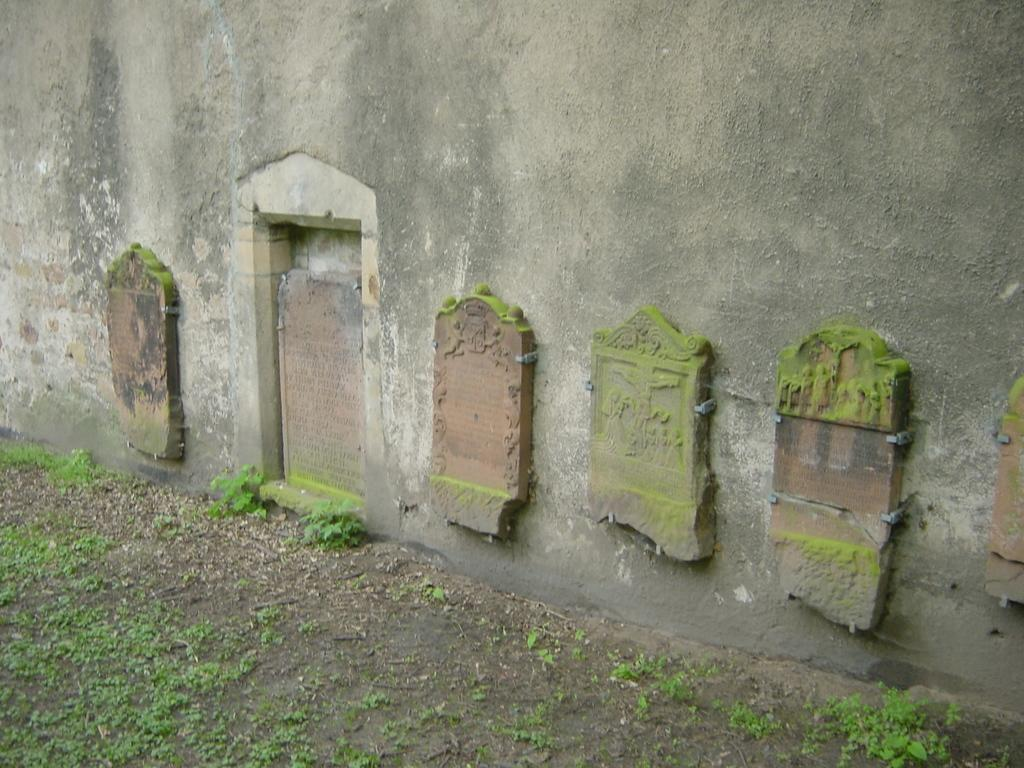What is at the bottom of the picture? There is soil and herbs at the bottom of the picture. What can be seen in the background of the image? There is a wall in the image. What is placed on the wall? Carved stones or carved wood are placed on the wall. How many bikes are leaning against the wall in the image? There are no bikes present in the image; it features soil, herbs, a wall, and carved stones or carved wood. Can you see a wing on any of the carved objects in the image? There is no wing visible on the carved stones or carved wood in the image. 